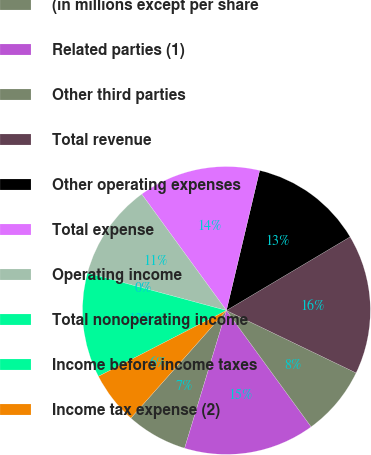<chart> <loc_0><loc_0><loc_500><loc_500><pie_chart><fcel>(in millions except per share<fcel>Related parties (1)<fcel>Other third parties<fcel>Total revenue<fcel>Other operating expenses<fcel>Total expense<fcel>Operating income<fcel>Total nonoperating income<fcel>Income before income taxes<fcel>Income tax expense (2)<nl><fcel>6.86%<fcel>14.7%<fcel>7.84%<fcel>15.68%<fcel>12.74%<fcel>13.72%<fcel>10.78%<fcel>0.0%<fcel>11.76%<fcel>5.88%<nl></chart> 